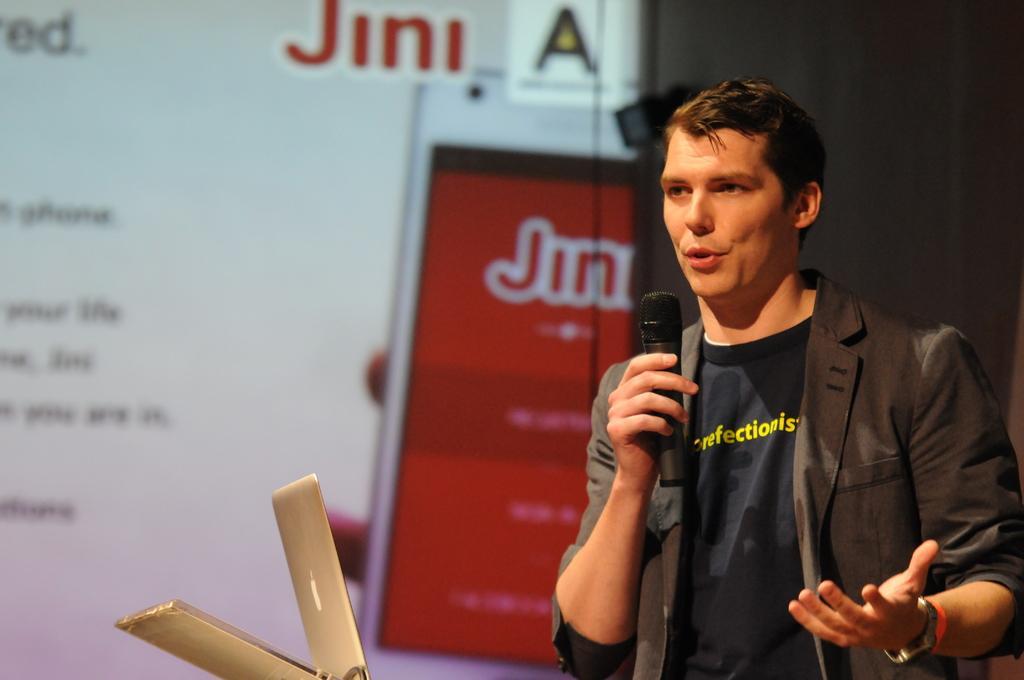Could you give a brief overview of what you see in this image? In this image I see a man who is holding a mic and there is a laptop in front of him. 